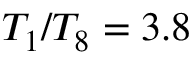<formula> <loc_0><loc_0><loc_500><loc_500>T _ { 1 } / T _ { 8 } = 3 . 8</formula> 